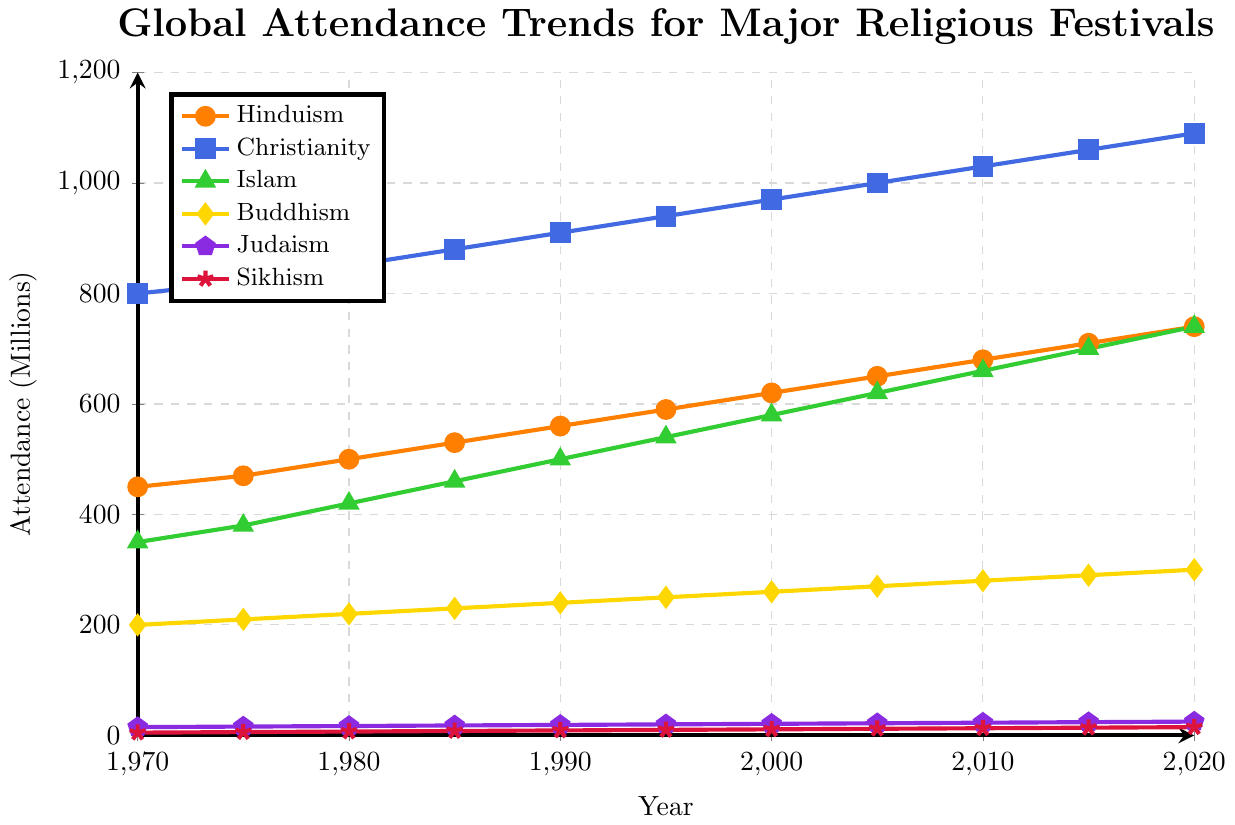What trend can be observed in the attendance for Christianity festivals from 1970 to 2020? The attendance for Christianity festivals shows a consistent upward trend from 800 million in 1970 to 1090 million in 2020. This steady increase can be seen in the upward slope of the line representing Christianity in the chart.
Answer: Consistent upward trend Which religion had the highest attendance in 2020? In 2020, Christianity has the highest attendance at 1090 million, which is clearly the peak of all plotted lines in the chart.
Answer: Christianity By how much did the attendance of Hinduism festivals increase from 1990 to 2020? In 1990, the attendance for Hinduism festivals was 560 million, and in 2020, it increased to 740 million. The difference between these values is 740 - 560.
Answer: 180 million Which two religions have similar attendance trends over the 50-year period, and what are the differences in their 2020 values? Islam and Hinduism have relatively similar upward trends over the 50-year period. In 2020, attendance for Islam is 740 million, and for Hinduism, it is also 740 million. The difference, therefore, is 0.
Answer: Hinduism and Islam, 0 Compare the growth rates between Buddhism and Sikhism from 1970 to 2020. In 1970, the attendance for Buddhism was 200 million and for Sikhism was 5 million. In 2020, these values are 300 million for Buddhism and 15 million for Sikhism. Growth for Buddhism is 300 - 200 = 100 million, and for Sikhism, it is 15 - 5 = 10 million. Comparing the increases, Buddhism has a higher growth amount than Sikhism.
Answer: Buddhism has a higher growth rate How much did the attendance for Judaism festivals grow from 1970 to 2020 compared to that of Sikhism? In 1970, the attendance for Judaism was 15 million and grew to 25 million by 2020, an increase of 25 - 15 = 10 million. For Sikhism, it grew from 5 million to 15 million, an increase of 15 - 5 = 10 million. The growth amounts are equal.
Answer: Equal growth of 10 million What is the average annual increase in attendance for Islam festivals between 1970 and 2020? The total increase in attendance from 1970 (350 million) to 2020 (740 million) is 740 - 350 = 390 million. Over 50 years, the average annual increase is 390 / 50.
Answer: 7.8 million per year Between which two consecutive 5-year periods did Christianity see the highest increase in attendance? By examining the data, the largest 5-year increases are observed between consecutive periods: 
- 1970 to 1975: 820 - 800 = 20 million
- 1975 to 1980: 850 - 820 = 30 million
- 1980 to 1985: 880 - 850 = 30 million 
- 1985 to 1990: 910 - 880 = 30 million
- 1990 to 1995: 940 - 910 = 30 million
- 1995 to 2000: 970 - 940 = 30 million
- 2000 to 2005: 1000 - 970 = 30 million
- 2005 to 2010: 1030 - 1000 = 30 million
- 2010 to 2015: 1060 - 1030 = 30 million
- 2015 to 2020: 1090 - 1060= 30 million
So the periods with the highest increase (30 million) occur between each set of consecutive periods from 1975 to 2020.
Answer: Several consecutive 5-year periods each with 30 million increase 